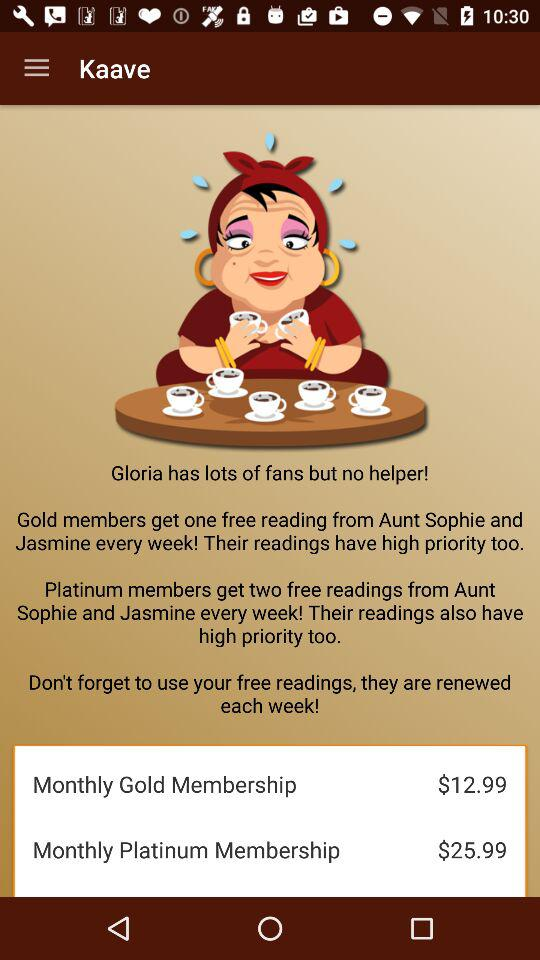What is the price of the monthly gold membership? The price of the monthly gold membership is $12.99. 